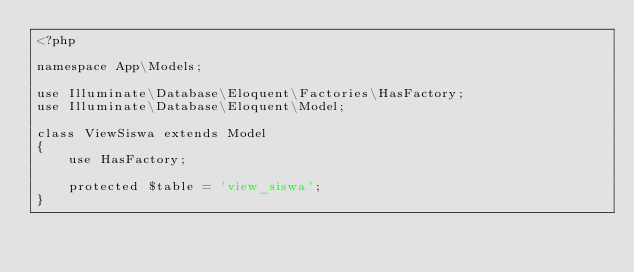Convert code to text. <code><loc_0><loc_0><loc_500><loc_500><_PHP_><?php

namespace App\Models;

use Illuminate\Database\Eloquent\Factories\HasFactory;
use Illuminate\Database\Eloquent\Model;

class ViewSiswa extends Model
{
    use HasFactory;

    protected $table = 'view_siswa';
}
</code> 